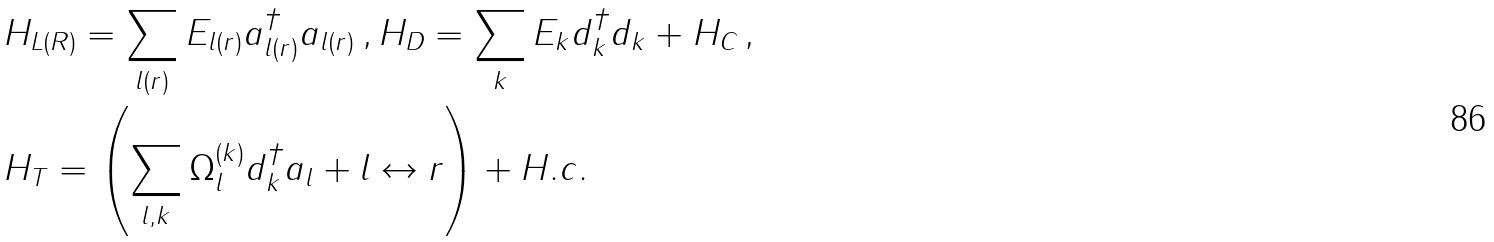Convert formula to latex. <formula><loc_0><loc_0><loc_500><loc_500>& H _ { L ( R ) } = \sum _ { l ( r ) } E _ { l ( r ) } a ^ { \dagger } _ { l ( r ) } a _ { l ( r ) } \, , H _ { D } = \sum _ { k } E _ { k } d ^ { \dagger } _ { k } d _ { k } + H _ { C } \, , \\ & H _ { T } = \left ( \sum _ { l , k } \Omega ^ { ( k ) } _ { l } d ^ { \dagger } _ { k } a _ { l } + l \leftrightarrow r \right ) + H . c .</formula> 